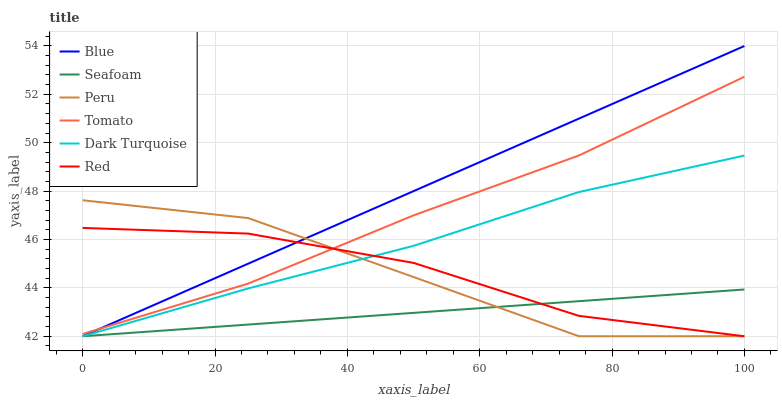Does Seafoam have the minimum area under the curve?
Answer yes or no. Yes. Does Blue have the maximum area under the curve?
Answer yes or no. Yes. Does Tomato have the minimum area under the curve?
Answer yes or no. No. Does Tomato have the maximum area under the curve?
Answer yes or no. No. Is Seafoam the smoothest?
Answer yes or no. Yes. Is Peru the roughest?
Answer yes or no. Yes. Is Tomato the smoothest?
Answer yes or no. No. Is Tomato the roughest?
Answer yes or no. No. Does Blue have the lowest value?
Answer yes or no. Yes. Does Tomato have the lowest value?
Answer yes or no. No. Does Blue have the highest value?
Answer yes or no. Yes. Does Tomato have the highest value?
Answer yes or no. No. Is Dark Turquoise less than Tomato?
Answer yes or no. Yes. Is Tomato greater than Seafoam?
Answer yes or no. Yes. Does Peru intersect Dark Turquoise?
Answer yes or no. Yes. Is Peru less than Dark Turquoise?
Answer yes or no. No. Is Peru greater than Dark Turquoise?
Answer yes or no. No. Does Dark Turquoise intersect Tomato?
Answer yes or no. No. 